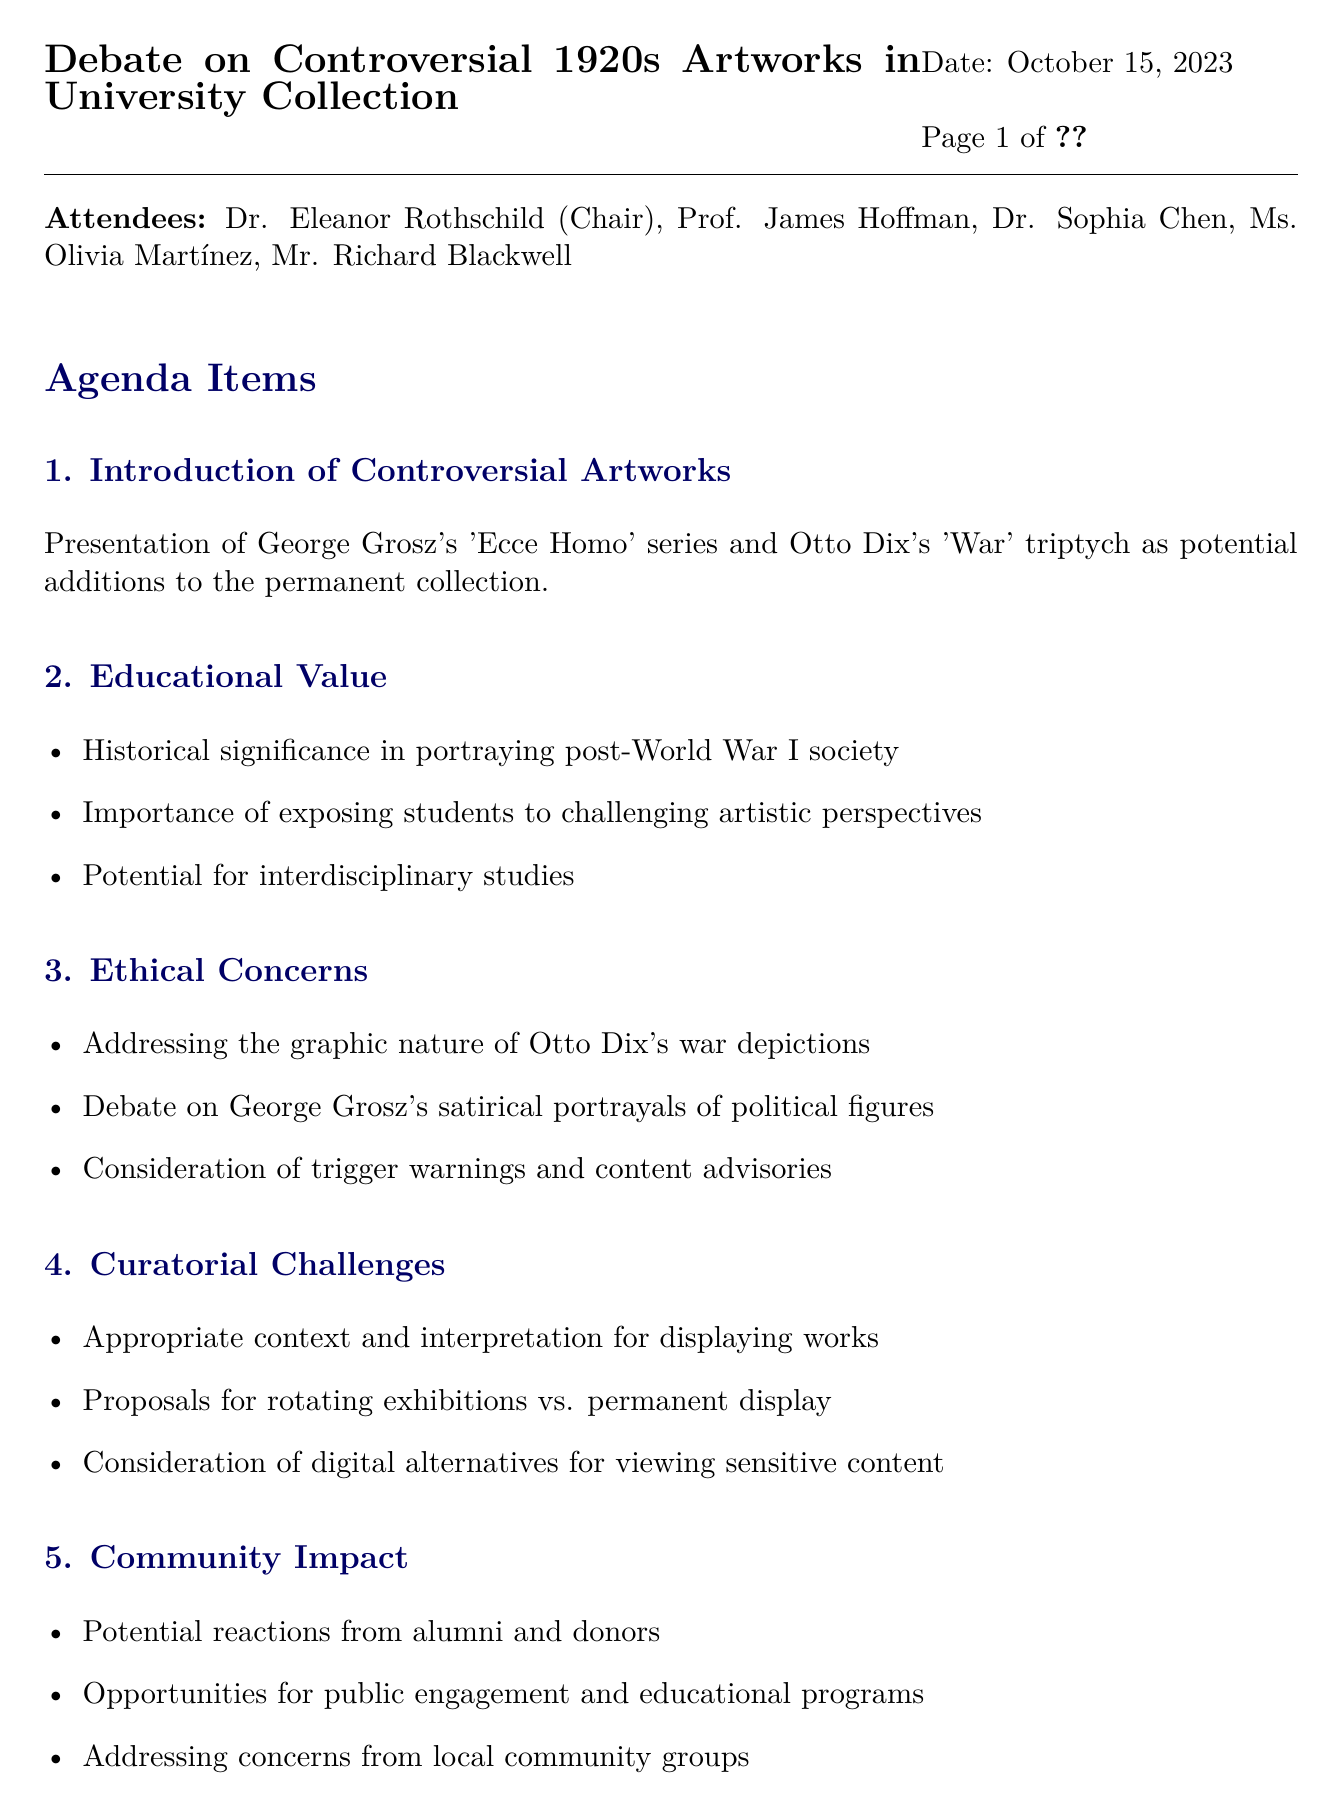What is the meeting title? The meeting title is stated at the beginning of the document.
Answer: Debate on Controversial 1920s Artworks in University Collection Who is the chair of the meeting? The document lists attendees and their roles, highlighting the chairperson.
Answer: Dr. Eleanor Rothschild What date was the meeting held? The date of the meeting is provided in the header of the document.
Answer: October 15, 2023 Which artwork by Otto Dix was discussed? The document mentions specific artworks that are potential additions to the collection.
Answer: War triptych What is one ethical concern mentioned in the meeting? The document lists points under the ethical concerns agenda item.
Answer: Graphic nature What are the proposed options for displaying the artworks? The agenda discusses various display options under curatorial challenges.
Answer: Rotating exhibitions vs. permanent display What is one potential benefit of including these artworks? The educational value section points to specific benefits of including the artworks.
Answer: Exposing students to challenging artistic perspectives Who recorded the minutes? The document has a placeholder indicating who recorded the minutes, which is typical in meeting minutes.
Answer: \_\_\_\_\_\_\_\_\_\_\_\_\_\_\_\_\_\_\_\_ What community aspect was discussed regarding the artworks? The document outlines the community impact as a separate agenda point.
Answer: Reactions from alumni and donors 